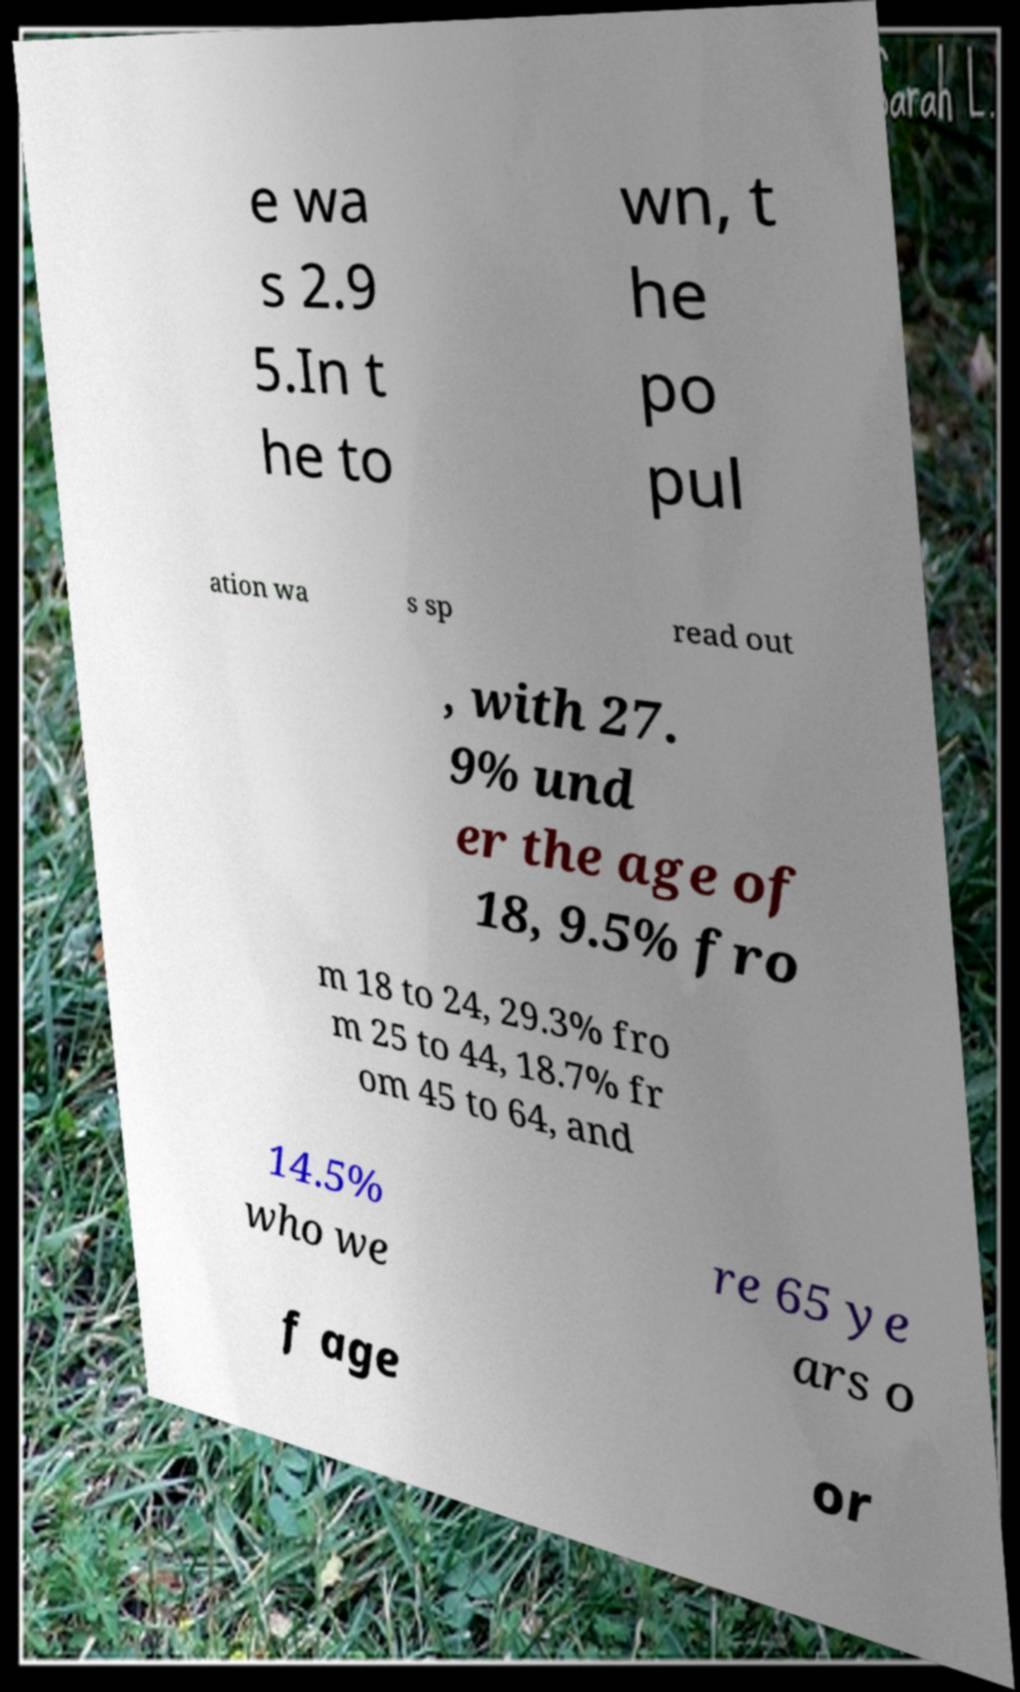Could you extract and type out the text from this image? e wa s 2.9 5.In t he to wn, t he po pul ation wa s sp read out , with 27. 9% und er the age of 18, 9.5% fro m 18 to 24, 29.3% fro m 25 to 44, 18.7% fr om 45 to 64, and 14.5% who we re 65 ye ars o f age or 